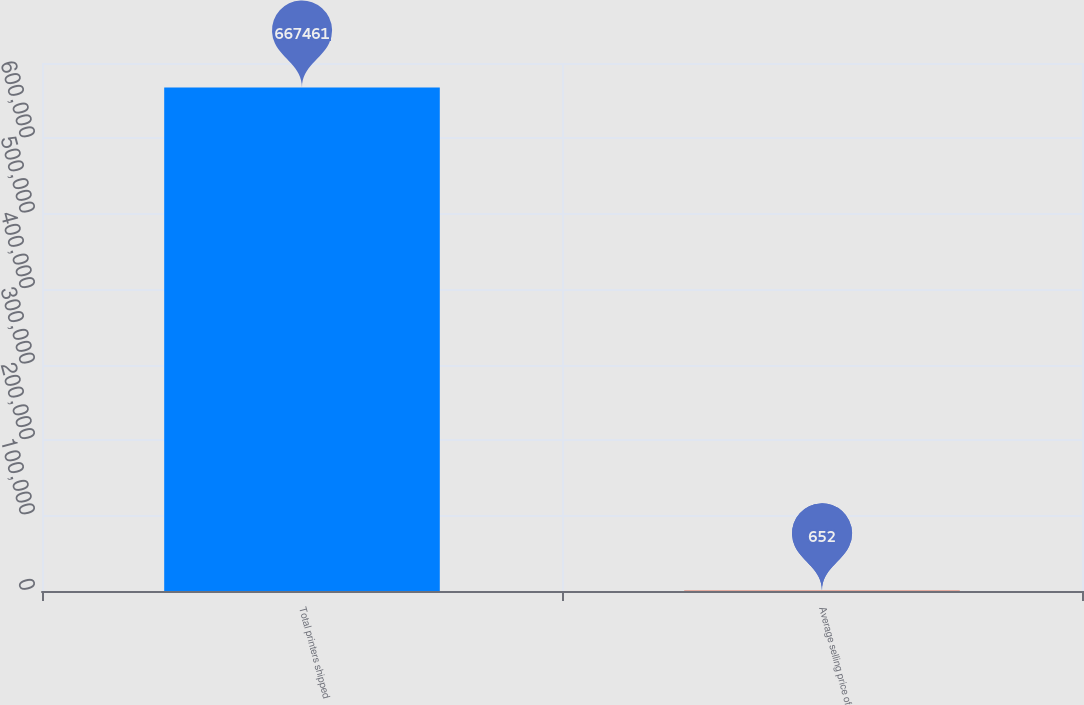<chart> <loc_0><loc_0><loc_500><loc_500><bar_chart><fcel>Total printers shipped<fcel>Average selling price of<nl><fcel>667461<fcel>652<nl></chart> 